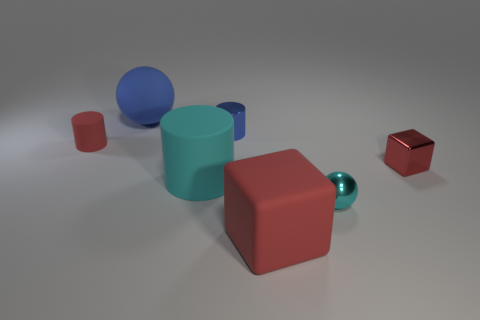Subtract all rubber cylinders. How many cylinders are left? 1 Subtract all blue cylinders. How many cylinders are left? 2 Add 3 cylinders. How many objects exist? 10 Subtract all cylinders. How many objects are left? 4 Subtract 1 cylinders. How many cylinders are left? 2 Subtract all gray cylinders. Subtract all blue blocks. How many cylinders are left? 3 Subtract all purple spheres. How many blue cylinders are left? 1 Subtract all cubes. Subtract all large gray metallic balls. How many objects are left? 5 Add 1 big red matte blocks. How many big red matte blocks are left? 2 Add 1 large objects. How many large objects exist? 4 